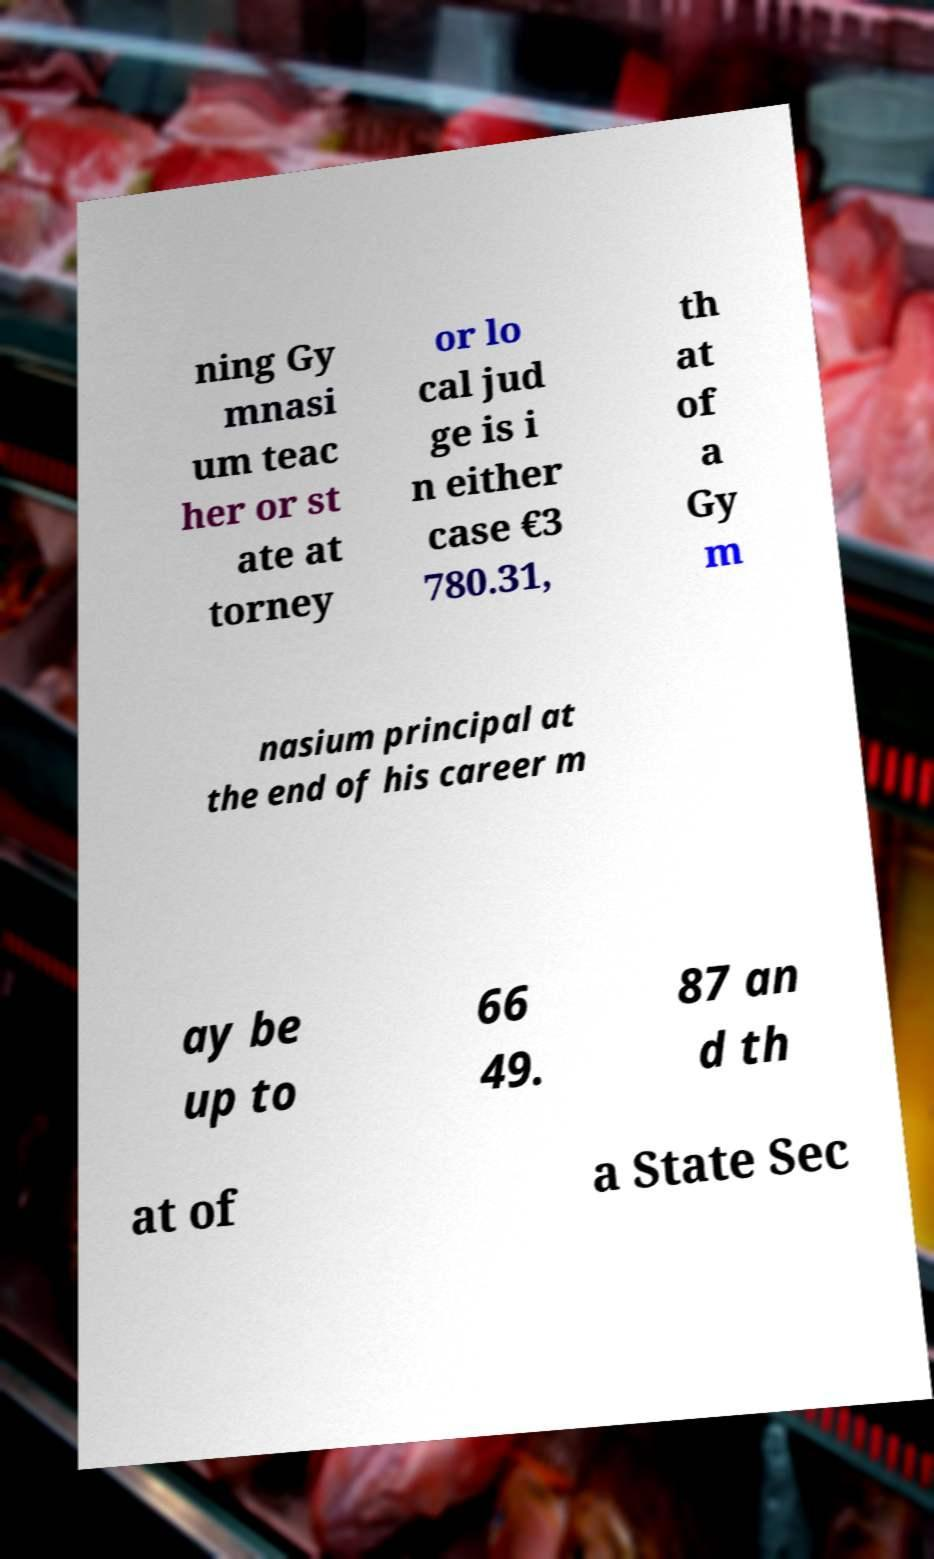Please read and relay the text visible in this image. What does it say? ning Gy mnasi um teac her or st ate at torney or lo cal jud ge is i n either case €3 780.31, th at of a Gy m nasium principal at the end of his career m ay be up to 66 49. 87 an d th at of a State Sec 